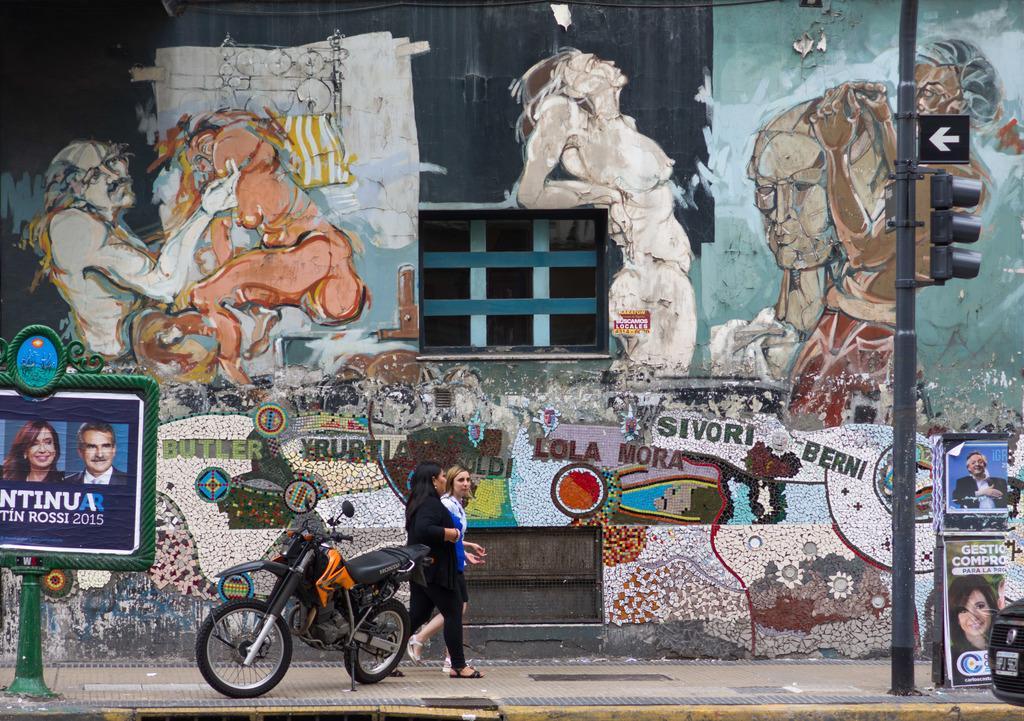Please provide a concise description of this image. In this picture we can see two persons are walking, on the left side and right side there are words, we can see a bike in the middle, on the right side there are traffic lights, a pole and a signboard, in the background there is a wall, we can see paintings on the wall. 